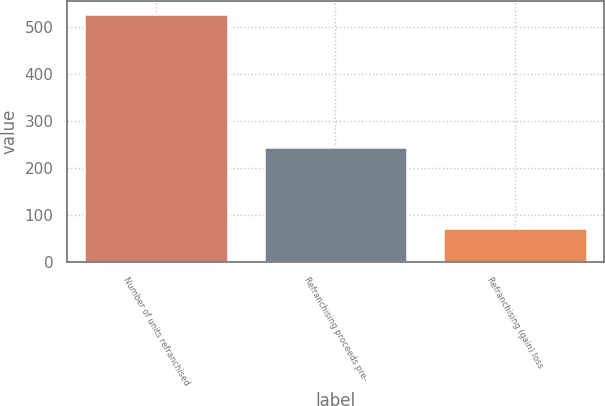<chart> <loc_0><loc_0><loc_500><loc_500><bar_chart><fcel>Number of units refranchised<fcel>Refranchising proceeds pre-<fcel>Refranchising (gain) loss<nl><fcel>529<fcel>246<fcel>72<nl></chart> 